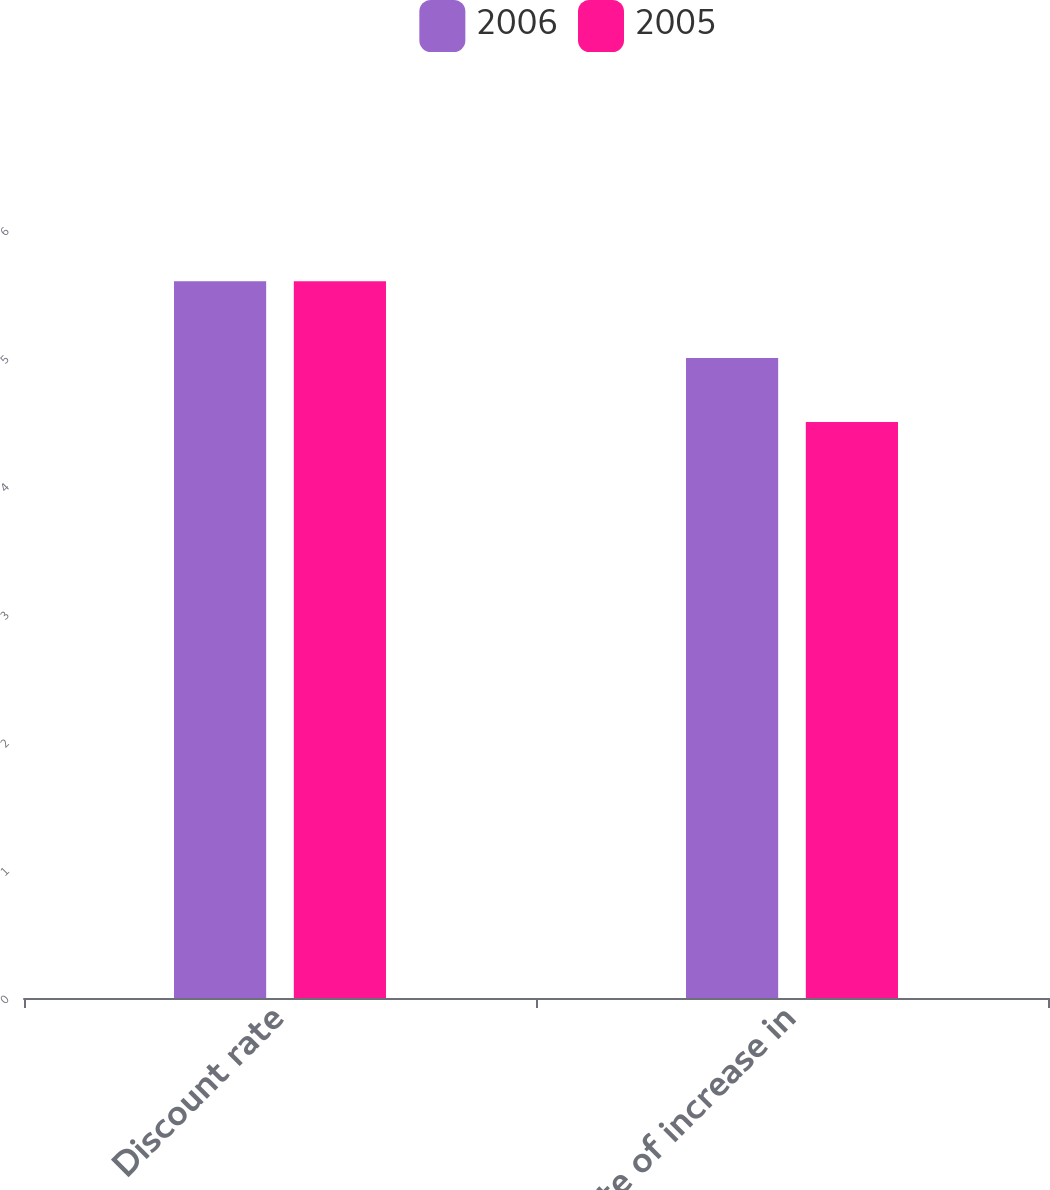Convert chart to OTSL. <chart><loc_0><loc_0><loc_500><loc_500><stacked_bar_chart><ecel><fcel>Discount rate<fcel>Rate of increase in<nl><fcel>2006<fcel>5.6<fcel>5<nl><fcel>2005<fcel>5.6<fcel>4.5<nl></chart> 